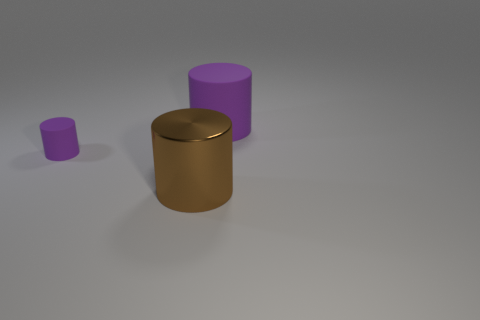There is a thing that is in front of the tiny purple object; is its size the same as the purple rubber cylinder that is to the left of the brown metal cylinder?
Make the answer very short. No. What number of purple objects have the same size as the brown shiny object?
Offer a terse response. 1. Are any small purple cylinders visible?
Keep it short and to the point. Yes. Is there anything else of the same color as the small object?
Offer a very short reply. Yes. The tiny purple thing that is the same material as the big purple thing is what shape?
Offer a terse response. Cylinder. There is a thing to the left of the metallic cylinder in front of the small cylinder to the left of the large matte cylinder; what is its color?
Your response must be concise. Purple. Is the number of big cylinders right of the tiny purple thing the same as the number of small cyan shiny blocks?
Provide a short and direct response. No. Are there any other things that have the same material as the tiny cylinder?
Offer a terse response. Yes. There is a small rubber object; does it have the same color as the big thing to the left of the large purple thing?
Your answer should be compact. No. Is there a brown cylinder that is right of the matte cylinder right of the purple cylinder left of the large purple cylinder?
Your answer should be compact. No. 